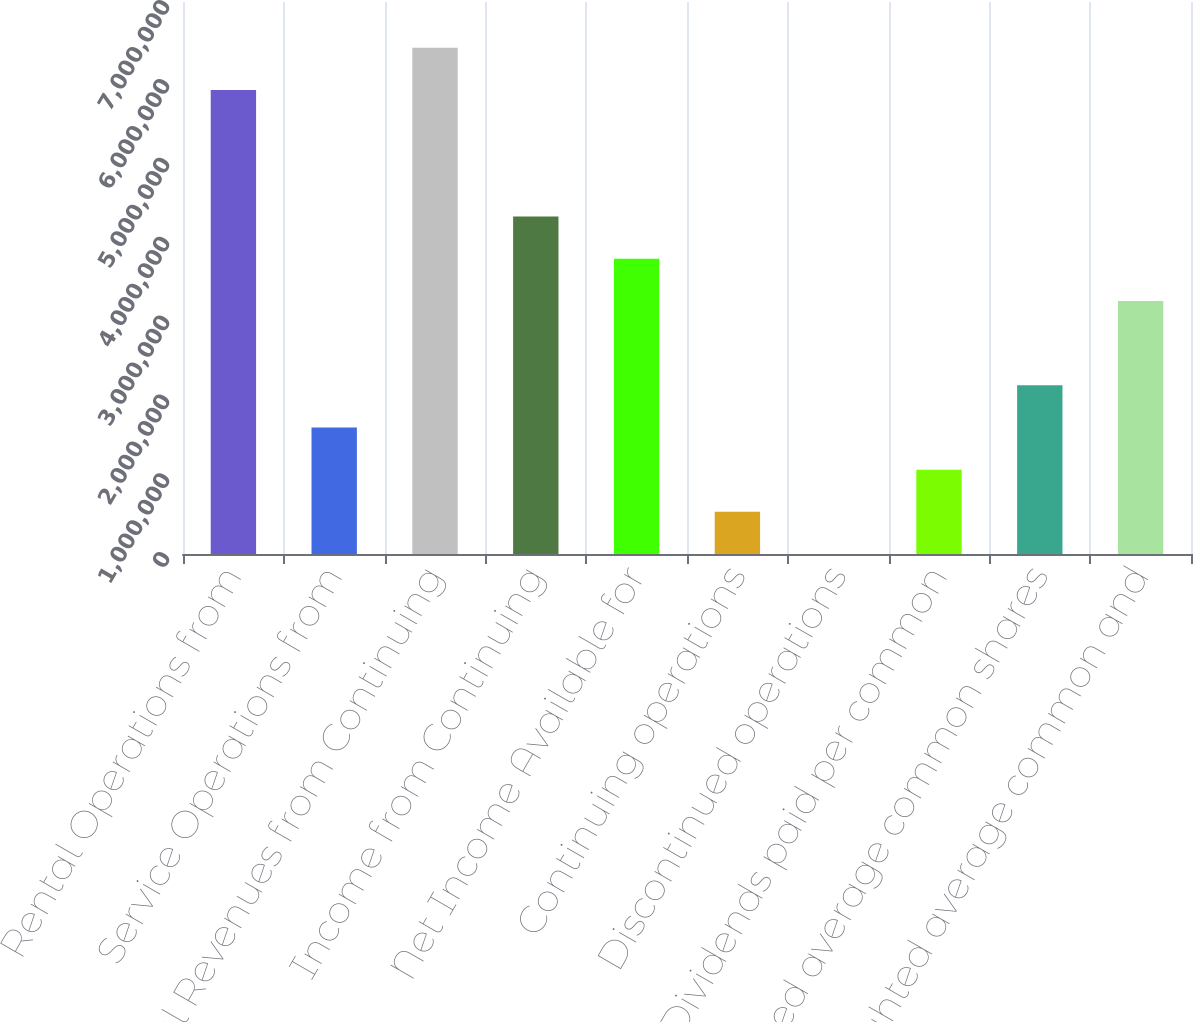<chart> <loc_0><loc_0><loc_500><loc_500><bar_chart><fcel>Rental Operations from<fcel>Service Operations from<fcel>Total Revenues from Continuing<fcel>Income from Continuing<fcel>Net Income Available for<fcel>Continuing operations<fcel>Discontinued operations<fcel>Dividends paid per common<fcel>Weighted average common shares<fcel>Weighted average common and<nl><fcel>5.88371e+06<fcel>1.60465e+06<fcel>6.41859e+06<fcel>4.27906e+06<fcel>3.74418e+06<fcel>534882<fcel>0.05<fcel>1.06976e+06<fcel>2.13953e+06<fcel>3.20929e+06<nl></chart> 